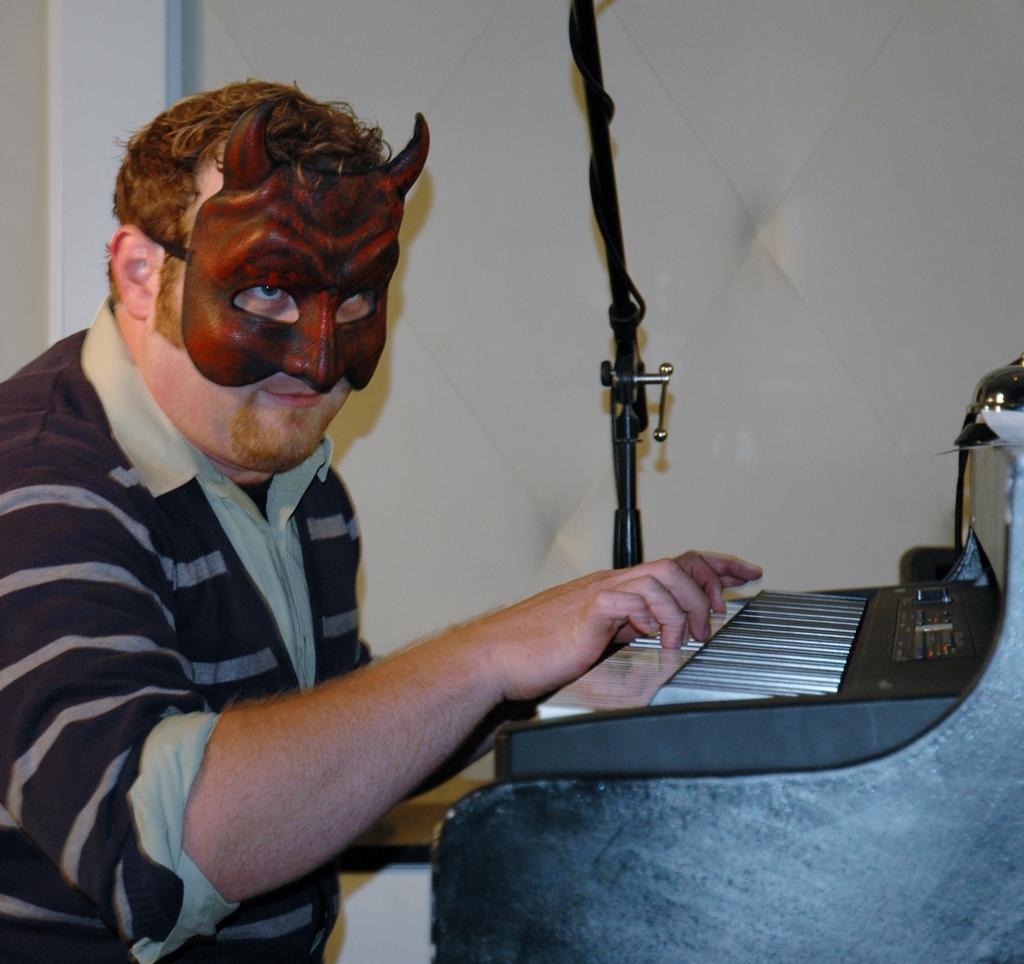Could you give a brief overview of what you see in this image? In this image there is a man sitting , wearing a mask and playing a piano and back ground there is a wall, and a rod. 